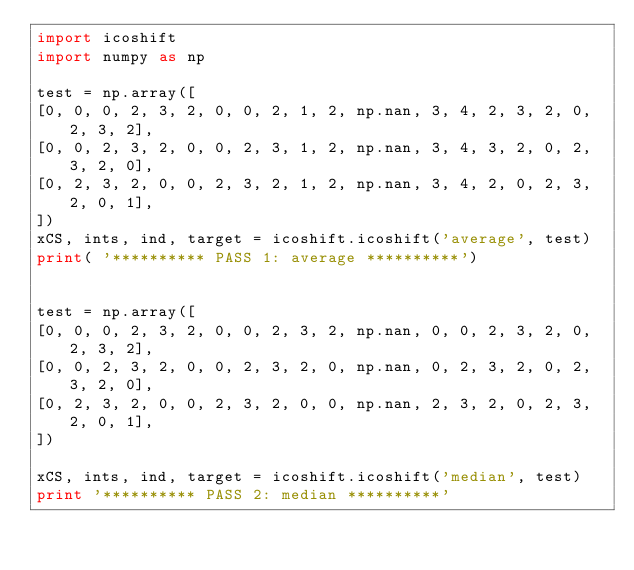Convert code to text. <code><loc_0><loc_0><loc_500><loc_500><_Python_>import icoshift
import numpy as np

test = np.array([
[0, 0, 0, 2, 3, 2, 0, 0, 2, 1, 2, np.nan, 3, 4, 2, 3, 2, 0, 2, 3, 2],
[0, 0, 2, 3, 2, 0, 0, 2, 3, 1, 2, np.nan, 3, 4, 3, 2, 0, 2, 3, 2, 0],
[0, 2, 3, 2, 0, 0, 2, 3, 2, 1, 2, np.nan, 3, 4, 2, 0, 2, 3, 2, 0, 1],
])
xCS, ints, ind, target = icoshift.icoshift('average', test)
print( '********** PASS 1: average **********')


test = np.array([
[0, 0, 0, 2, 3, 2, 0, 0, 2, 3, 2, np.nan, 0, 0, 2, 3, 2, 0, 2, 3, 2],
[0, 0, 2, 3, 2, 0, 0, 2, 3, 2, 0, np.nan, 0, 2, 3, 2, 0, 2, 3, 2, 0],
[0, 2, 3, 2, 0, 0, 2, 3, 2, 0, 0, np.nan, 2, 3, 2, 0, 2, 3, 2, 0, 1],
])

xCS, ints, ind, target = icoshift.icoshift('median', test)
print '********** PASS 2: median **********'
</code> 